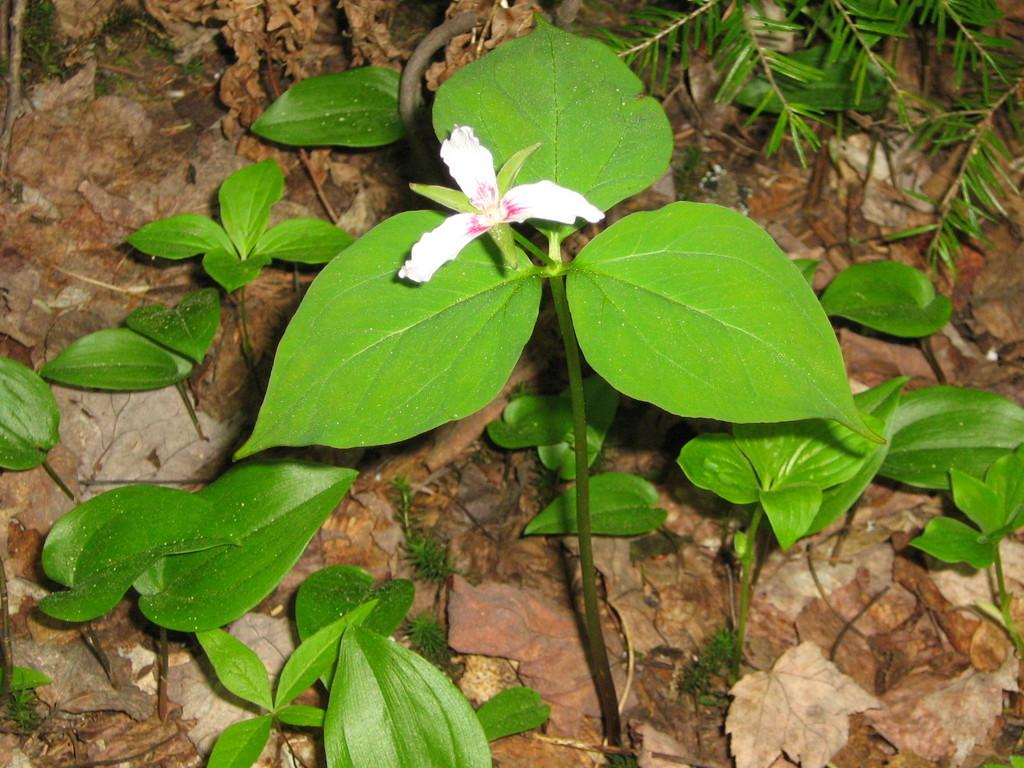What celestial bodies are shown in the image? There are planets depicted in the image. What type of plant is visible in the image? There is a flower in the image. What type of vegetation is on the ground in the image? There are leaves on the ground in the image. What type of dog can be seen playing with the planets in the image? There is no dog present in the image, and therefore no such activity can be observed. 